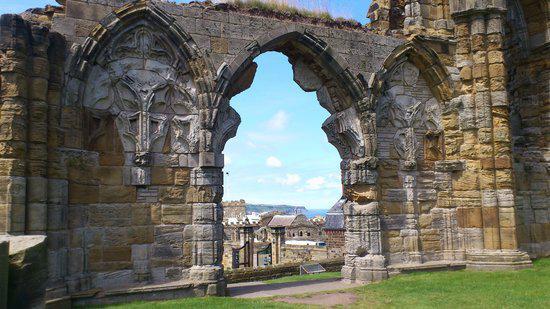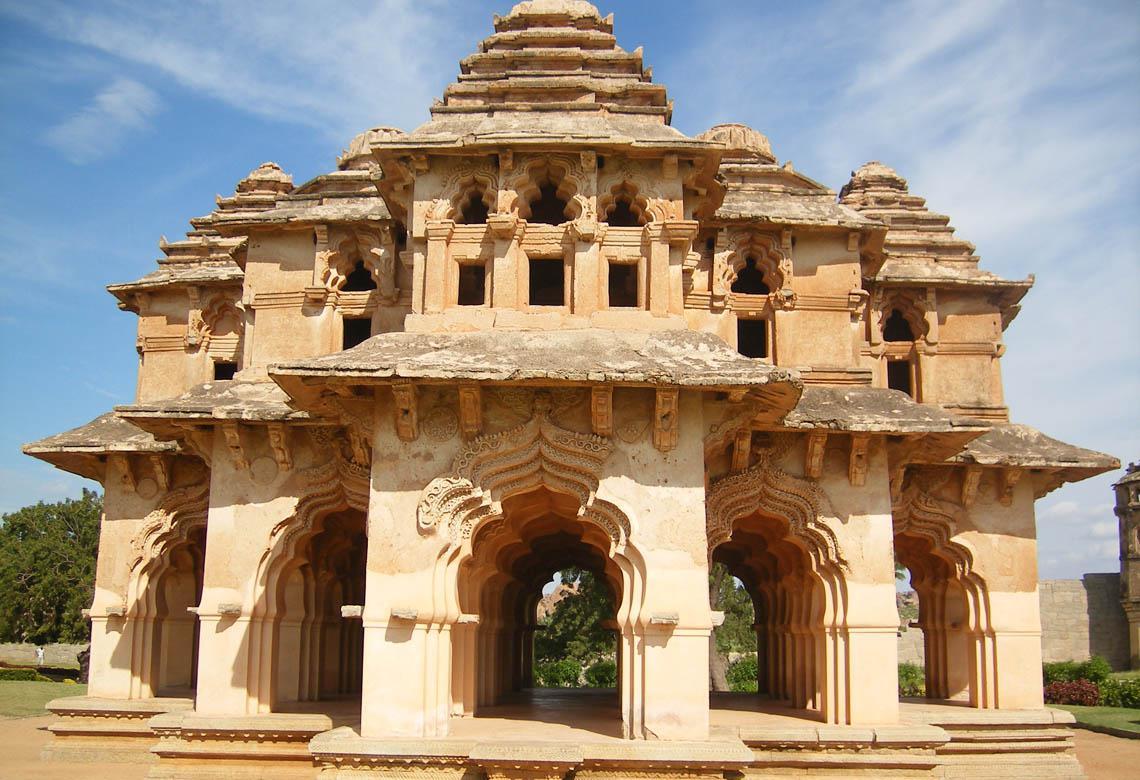The first image is the image on the left, the second image is the image on the right. Examine the images to the left and right. Is the description "There is no grass or other vegetation in any of the images." accurate? Answer yes or no. No. The first image is the image on the left, the second image is the image on the right. Examine the images to the left and right. Is the description "The right image has no more than 4 arches." accurate? Answer yes or no. No. 